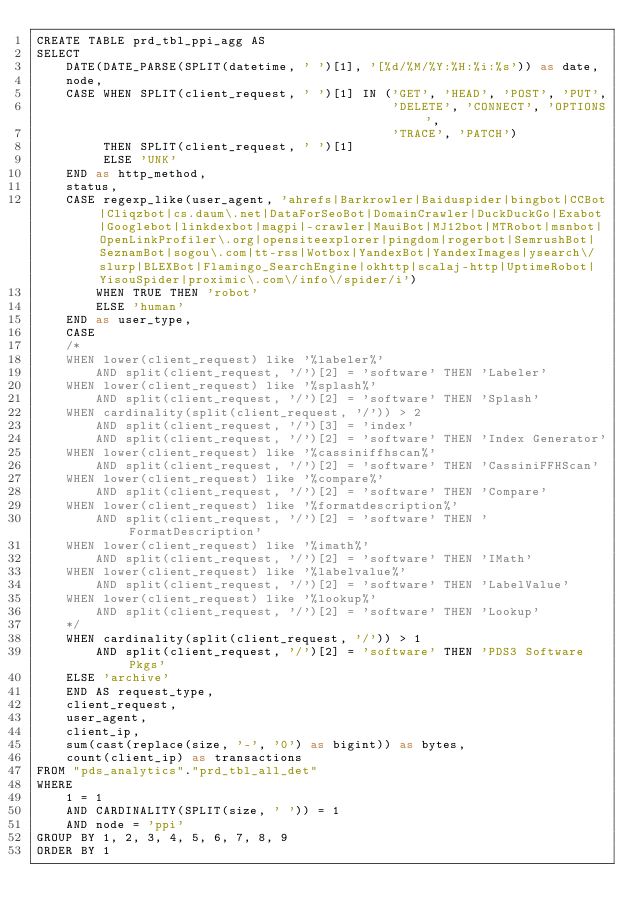<code> <loc_0><loc_0><loc_500><loc_500><_SQL_>CREATE TABLE prd_tbl_ppi_agg AS
SELECT
    DATE(DATE_PARSE(SPLIT(datetime, ' ')[1], '[%d/%M/%Y:%H:%i:%s')) as date,
    node,
    CASE WHEN SPLIT(client_request, ' ')[1] IN ('GET', 'HEAD', 'POST', 'PUT',
                                                'DELETE', 'CONNECT', 'OPTIONS',
                                                'TRACE', 'PATCH')
         THEN SPLIT(client_request, ' ')[1]
         ELSE 'UNK'
    END as http_method,
    status,
    CASE regexp_like(user_agent, 'ahrefs|Barkrowler|Baiduspider|bingbot|CCBot|Cliqzbot|cs.daum\.net|DataForSeoBot|DomainCrawler|DuckDuckGo|Exabot|Googlebot|linkdexbot|magpi|-crawler|MauiBot|MJ12bot|MTRobot|msnbot|OpenLinkProfiler\.org|opensiteexplorer|pingdom|rogerbot|SemrushBot|SeznamBot|sogou\.com|tt-rss|Wotbox|YandexBot|YandexImages|ysearch\/slurp|BLEXBot|Flamingo_SearchEngine|okhttp|scalaj-http|UptimeRobot|YisouSpider|proximic\.com\/info\/spider/i')
        WHEN TRUE THEN 'robot'
        ELSE 'human'
    END as user_type,
    CASE
    /*
    WHEN lower(client_request) like '%labeler%'
        AND split(client_request, '/')[2] = 'software' THEN 'Labeler'
    WHEN lower(client_request) like '%splash%'
        AND split(client_request, '/')[2] = 'software' THEN 'Splash'
    WHEN cardinality(split(client_request, '/')) > 2
        AND split(client_request, '/')[3] = 'index'
        AND split(client_request, '/')[2] = 'software' THEN 'Index Generator'
    WHEN lower(client_request) like '%cassiniffhscan%'
        AND split(client_request, '/')[2] = 'software' THEN 'CassiniFFHScan'
    WHEN lower(client_request) like '%compare%'
        AND split(client_request, '/')[2] = 'software' THEN 'Compare'
    WHEN lower(client_request) like '%formatdescription%'
        AND split(client_request, '/')[2] = 'software' THEN 'FormatDescription'
    WHEN lower(client_request) like '%imath%'
        AND split(client_request, '/')[2] = 'software' THEN 'IMath'
    WHEN lower(client_request) like '%labelvalue%'
        AND split(client_request, '/')[2] = 'software' THEN 'LabelValue'
    WHEN lower(client_request) like '%lookup%'
        AND split(client_request, '/')[2] = 'software' THEN 'Lookup'
    */
    WHEN cardinality(split(client_request, '/')) > 1
        AND split(client_request, '/')[2] = 'software' THEN 'PDS3 Software Pkgs'
    ELSE 'archive'
    END AS request_type,
    client_request,
    user_agent,
    client_ip,
    sum(cast(replace(size, '-', '0') as bigint)) as bytes,
    count(client_ip) as transactions
FROM "pds_analytics"."prd_tbl_all_det"
WHERE
    1 = 1
    AND CARDINALITY(SPLIT(size, ' ')) = 1
    AND node = 'ppi'
GROUP BY 1, 2, 3, 4, 5, 6, 7, 8, 9
ORDER BY 1</code> 